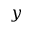<formula> <loc_0><loc_0><loc_500><loc_500>y</formula> 